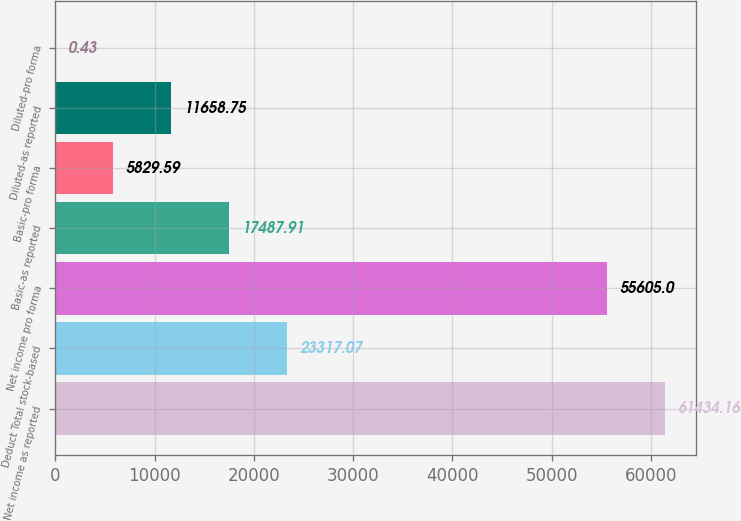Convert chart to OTSL. <chart><loc_0><loc_0><loc_500><loc_500><bar_chart><fcel>Net income as reported<fcel>Deduct Total stock-based<fcel>Net income pro forma<fcel>Basic-as reported<fcel>Basic-pro forma<fcel>Diluted-as reported<fcel>Diluted-pro forma<nl><fcel>61434.2<fcel>23317.1<fcel>55605<fcel>17487.9<fcel>5829.59<fcel>11658.8<fcel>0.43<nl></chart> 